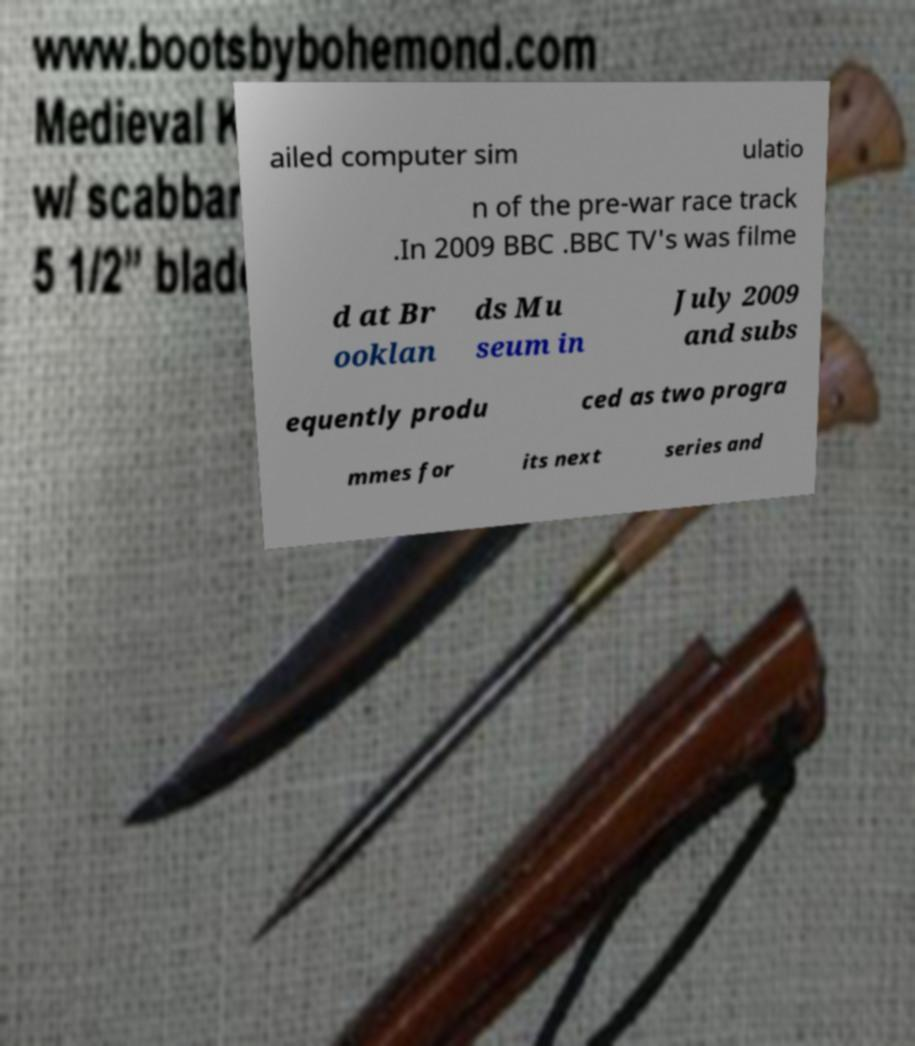Can you read and provide the text displayed in the image?This photo seems to have some interesting text. Can you extract and type it out for me? ailed computer sim ulatio n of the pre-war race track .In 2009 BBC .BBC TV's was filme d at Br ooklan ds Mu seum in July 2009 and subs equently produ ced as two progra mmes for its next series and 